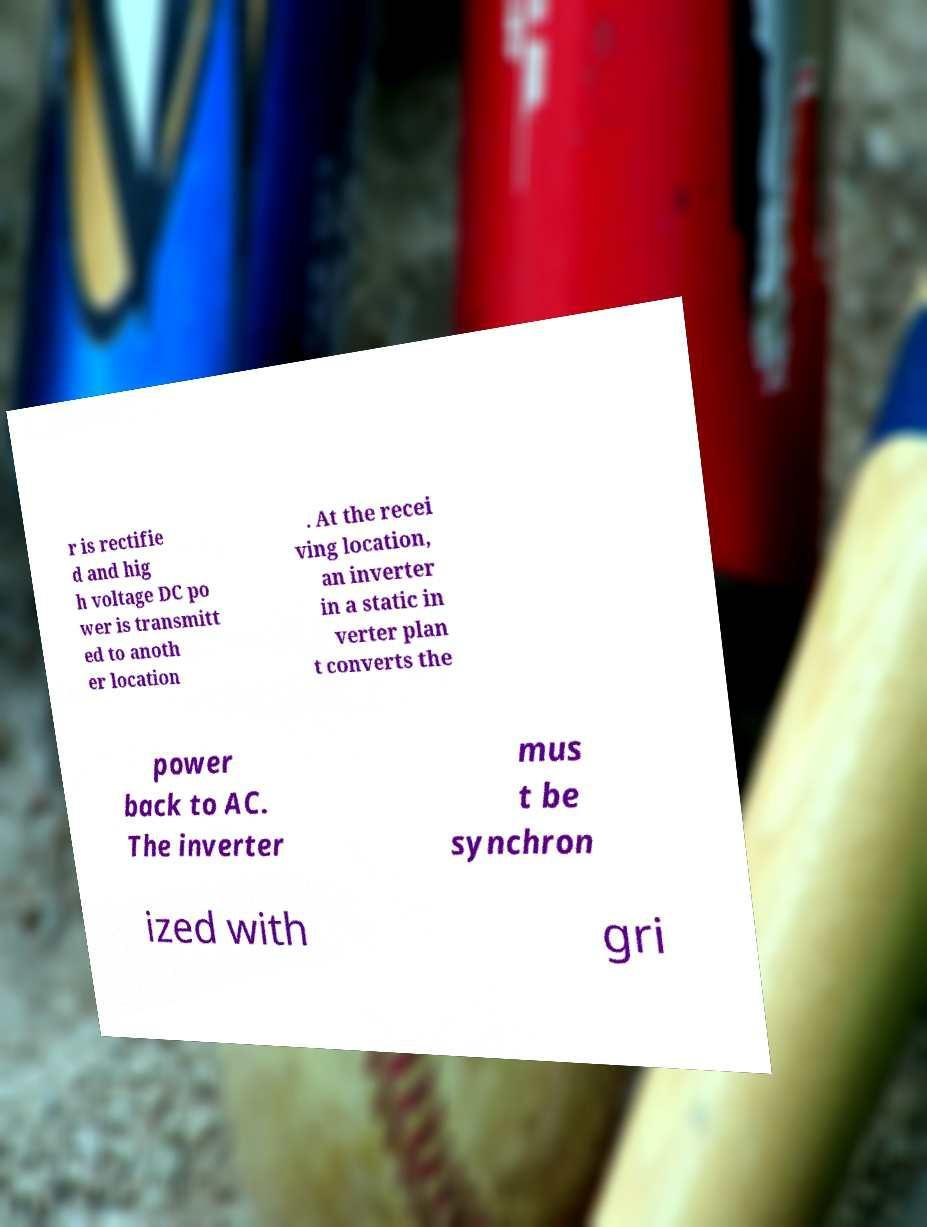Could you extract and type out the text from this image? r is rectifie d and hig h voltage DC po wer is transmitt ed to anoth er location . At the recei ving location, an inverter in a static in verter plan t converts the power back to AC. The inverter mus t be synchron ized with gri 